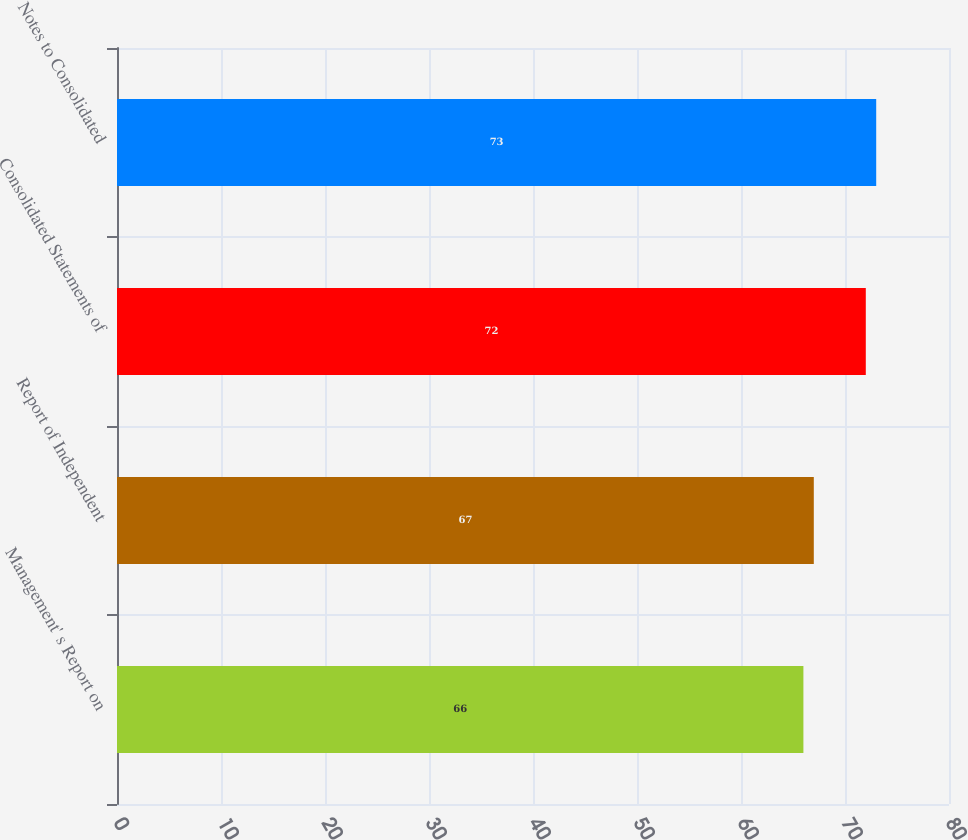Convert chart. <chart><loc_0><loc_0><loc_500><loc_500><bar_chart><fcel>Management' s Report on<fcel>Report of Independent<fcel>Consolidated Statements of<fcel>Notes to Consolidated<nl><fcel>66<fcel>67<fcel>72<fcel>73<nl></chart> 